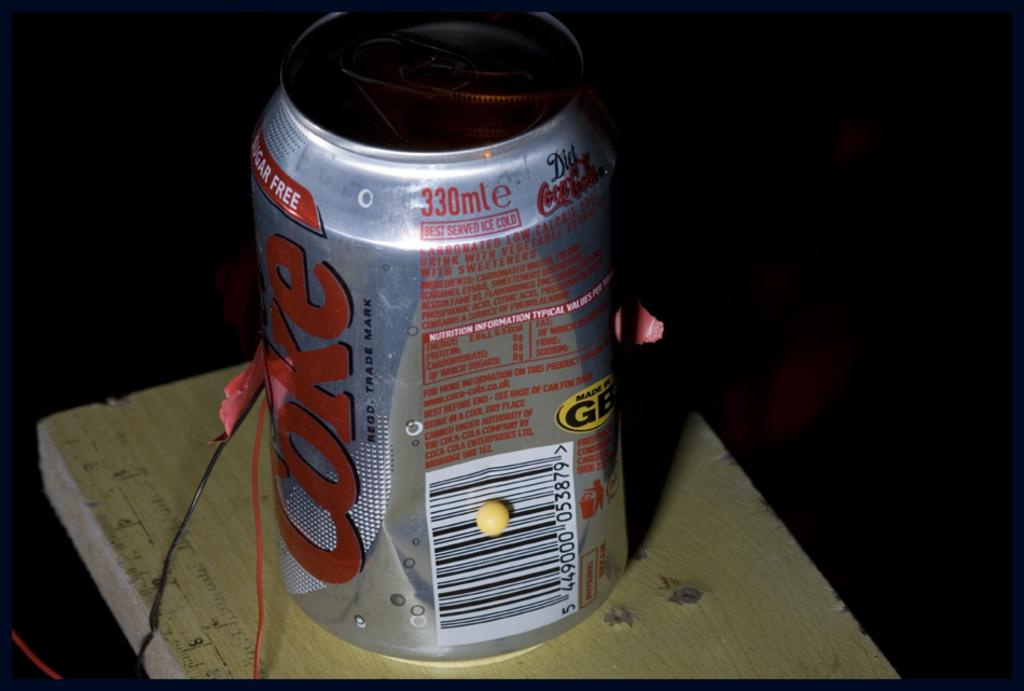<image>
Describe the image concisely. A can of Coke has a yellow tag that says it was made in GB. 